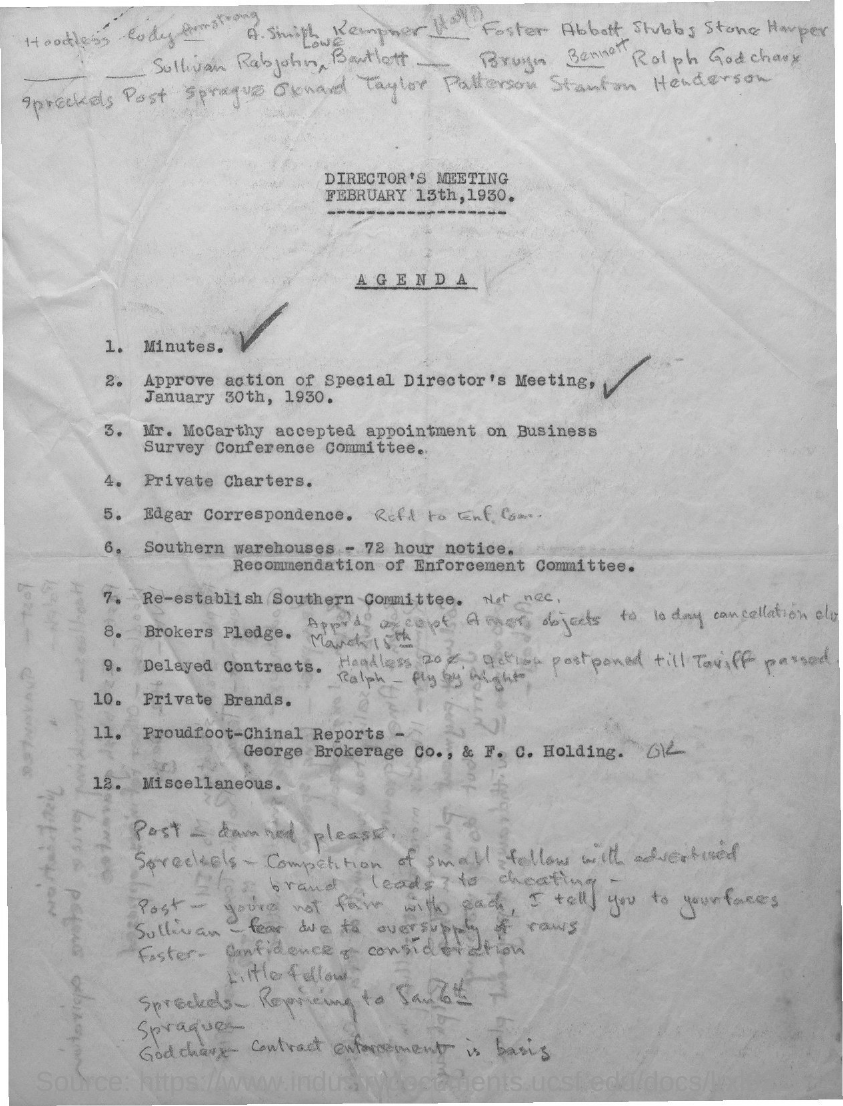Indicate a few pertinent items in this graphic. On February 13th, 1930, the director's meeting was held according to the agenda. 